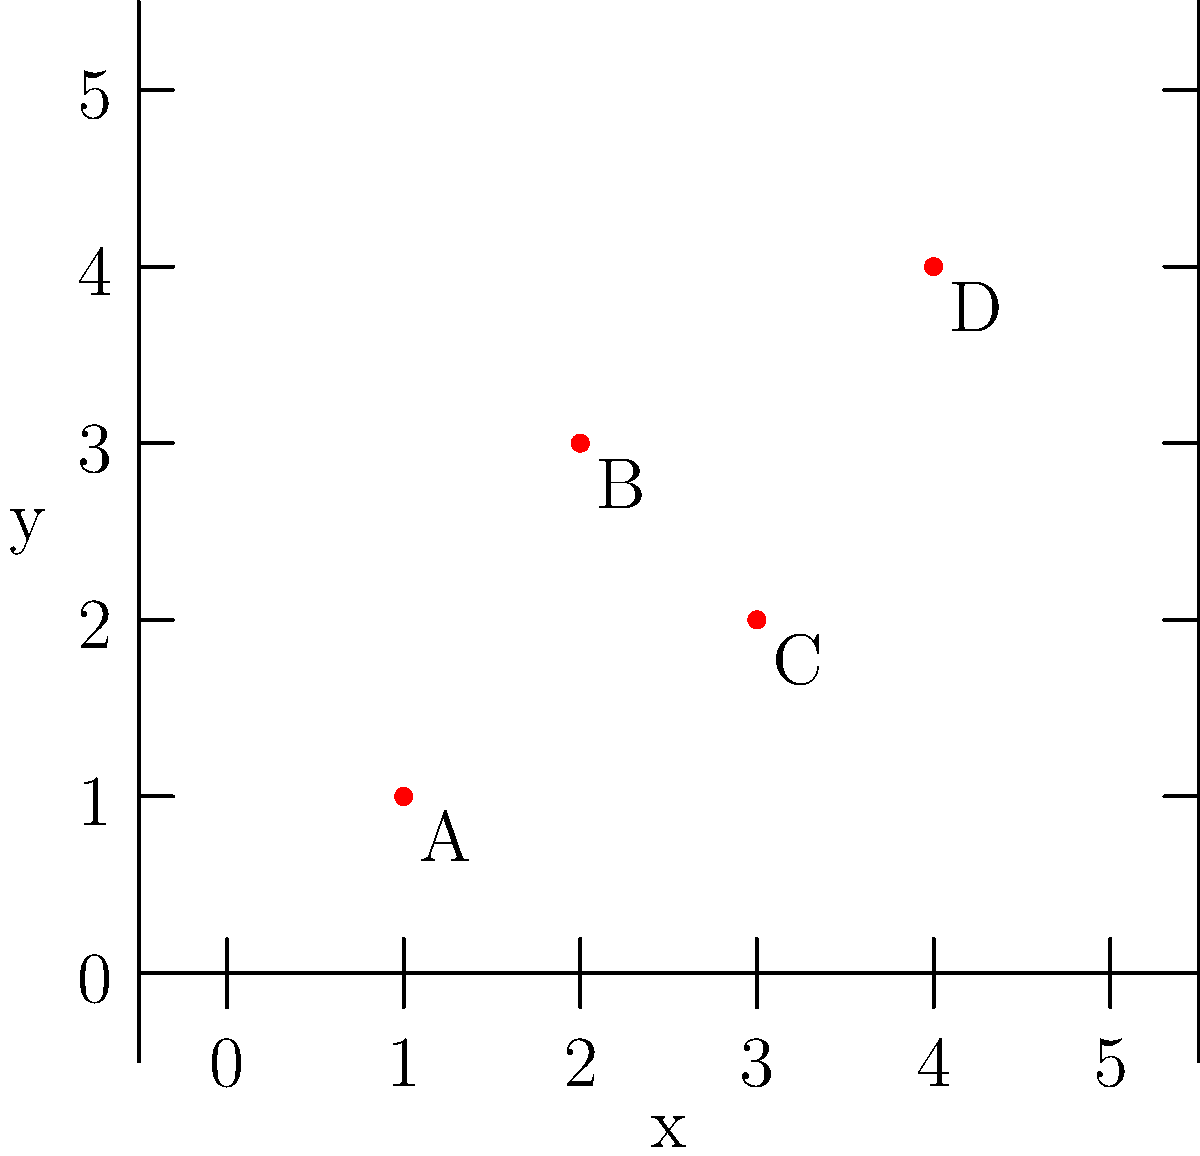A botanist has identified four locations of a rare plant species in different zones of the city. The locations are mapped on a grid coordinate system as shown above. What is the total distance, in grid units, that needs to be covered to visit all four locations in the order A → B → C → D? To solve this problem, we need to calculate the distance between each pair of consecutive points and then sum these distances. We can use the distance formula between two points: $d = \sqrt{(x_2-x_1)^2 + (y_2-y_1)^2}$

Step 1: Calculate distance from A(1,1) to B(2,3)
$d_{AB} = \sqrt{(2-1)^2 + (3-1)^2} = \sqrt{1^2 + 2^2} = \sqrt{5}$

Step 2: Calculate distance from B(2,3) to C(3,2)
$d_{BC} = \sqrt{(3-2)^2 + (2-3)^2} = \sqrt{1^2 + (-1)^2} = \sqrt{2}$

Step 3: Calculate distance from C(3,2) to D(4,4)
$d_{CD} = \sqrt{(4-3)^2 + (4-2)^2} = \sqrt{1^2 + 2^2} = \sqrt{5}$

Step 4: Sum all distances
Total distance = $d_{AB} + d_{BC} + d_{CD} = \sqrt{5} + \sqrt{2} + \sqrt{5} = 2\sqrt{5} + \sqrt{2}$

The total distance is $2\sqrt{5} + \sqrt{2}$ grid units.
Answer: $2\sqrt{5} + \sqrt{2}$ grid units 